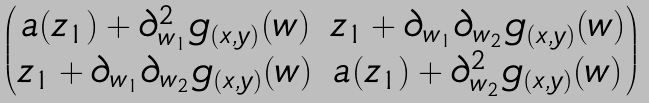<formula> <loc_0><loc_0><loc_500><loc_500>\begin{pmatrix} a ( z _ { 1 } ) + \partial _ { w _ { 1 } } ^ { 2 } g _ { ( x , y ) } ( w ) & z _ { 1 } + \partial _ { w _ { 1 } } \partial _ { w _ { 2 } } g _ { ( x , y ) } ( w ) \\ z _ { 1 } + \partial _ { w _ { 1 } } \partial _ { w _ { 2 } } g _ { ( x , y ) } ( w ) & a ( z _ { 1 } ) + \partial _ { w _ { 2 } } ^ { 2 } g _ { ( x , y ) } ( w ) \end{pmatrix}</formula> 